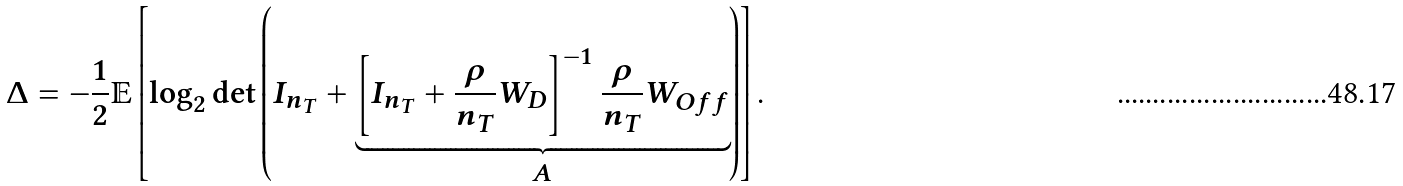<formula> <loc_0><loc_0><loc_500><loc_500>\Delta = - \frac { 1 } { 2 } \mathbb { E } \left [ \log _ { 2 } \det \left ( I _ { n _ { T } } + \underbrace { \left [ I _ { n _ { T } } + \frac { \rho } { n _ { T } } W _ { D } \right ] ^ { - 1 } \frac { \rho } { n _ { T } } W _ { O f f } } _ { A } \right ) \right ] .</formula> 